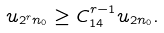Convert formula to latex. <formula><loc_0><loc_0><loc_500><loc_500>u _ { 2 ^ { r } n _ { 0 } } \geq C _ { 1 4 } ^ { r - 1 } u _ { 2 n _ { 0 } } .</formula> 